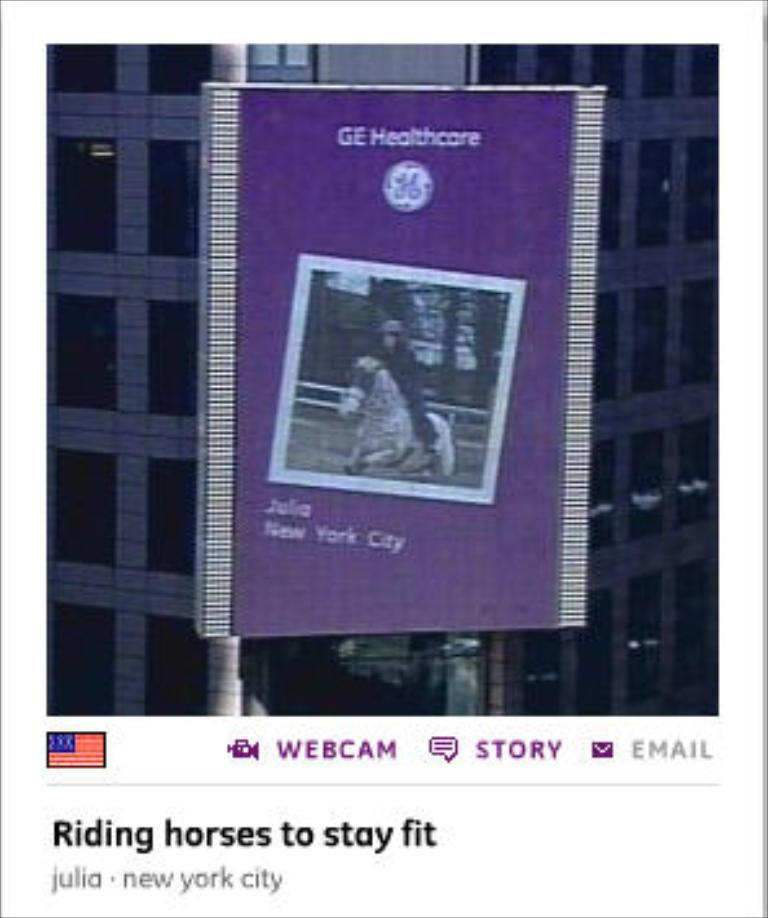What type of visual representation is shown in the image? The image is a poster. What is the main subject depicted on the poster? There is a book depicted on the poster. What else can be seen on the poster besides the book? There is a building depicted on the poster, as well as symbols and text. What type of flower is growing in front of the building on the poster? There is no flower present in the image; it is a poster featuring a book, a building, symbols, and text. 